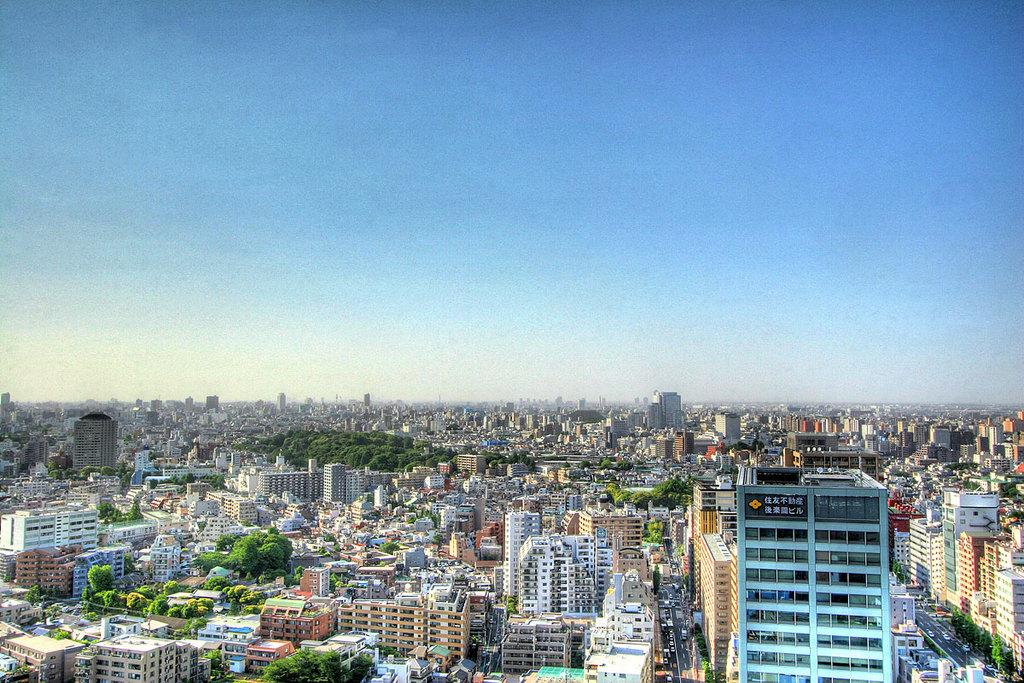What type of view is shown in the image? The image is an aerial view of a city. What can be seen in the majority of the image? There are many buildings in the image. Are there any natural elements visible in the image? Yes, trees are present in some areas of the image. What is visible in the background of the image? The sky is visible in the image. What type of bun is being used to hold the city together in the image? There is no bun present in the image, and the city is not being held together by any such object. 